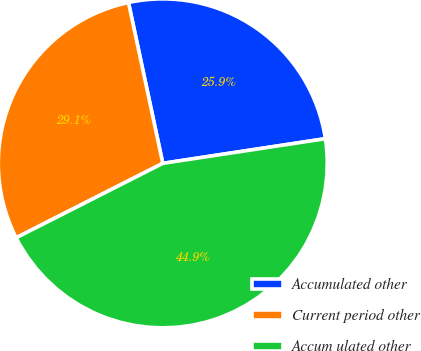<chart> <loc_0><loc_0><loc_500><loc_500><pie_chart><fcel>Accumulated other<fcel>Current period other<fcel>Accum ulated other<nl><fcel>25.95%<fcel>29.13%<fcel>44.92%<nl></chart> 